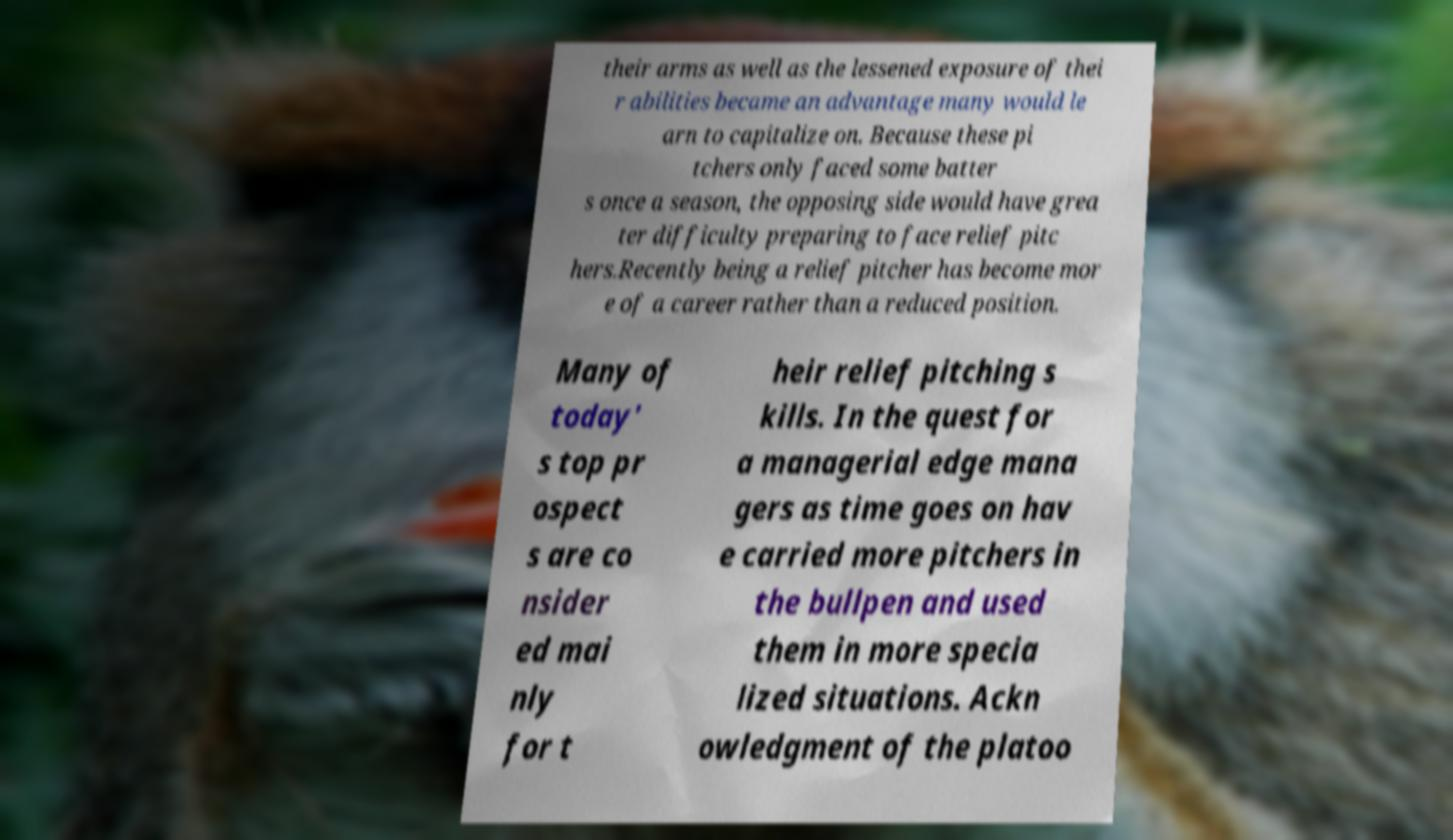Could you extract and type out the text from this image? their arms as well as the lessened exposure of thei r abilities became an advantage many would le arn to capitalize on. Because these pi tchers only faced some batter s once a season, the opposing side would have grea ter difficulty preparing to face relief pitc hers.Recently being a relief pitcher has become mor e of a career rather than a reduced position. Many of today' s top pr ospect s are co nsider ed mai nly for t heir relief pitching s kills. In the quest for a managerial edge mana gers as time goes on hav e carried more pitchers in the bullpen and used them in more specia lized situations. Ackn owledgment of the platoo 